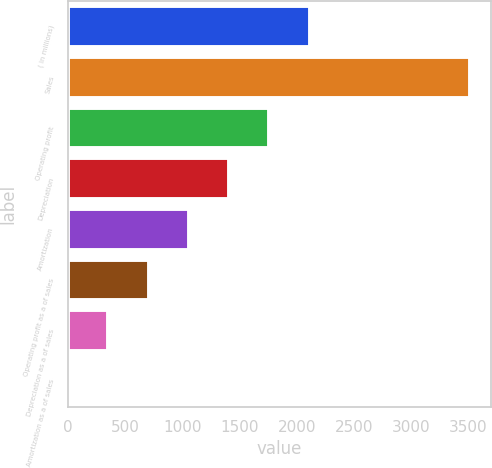<chart> <loc_0><loc_0><loc_500><loc_500><bar_chart><fcel>( in millions)<fcel>Sales<fcel>Operating profit<fcel>Depreciation<fcel>Amortization<fcel>Operating profit as a of sales<fcel>Depreciation as a of sales<fcel>Amortization as a of sales<nl><fcel>2110.42<fcel>3516.9<fcel>1758.8<fcel>1407.18<fcel>1055.56<fcel>703.94<fcel>352.32<fcel>0.7<nl></chart> 